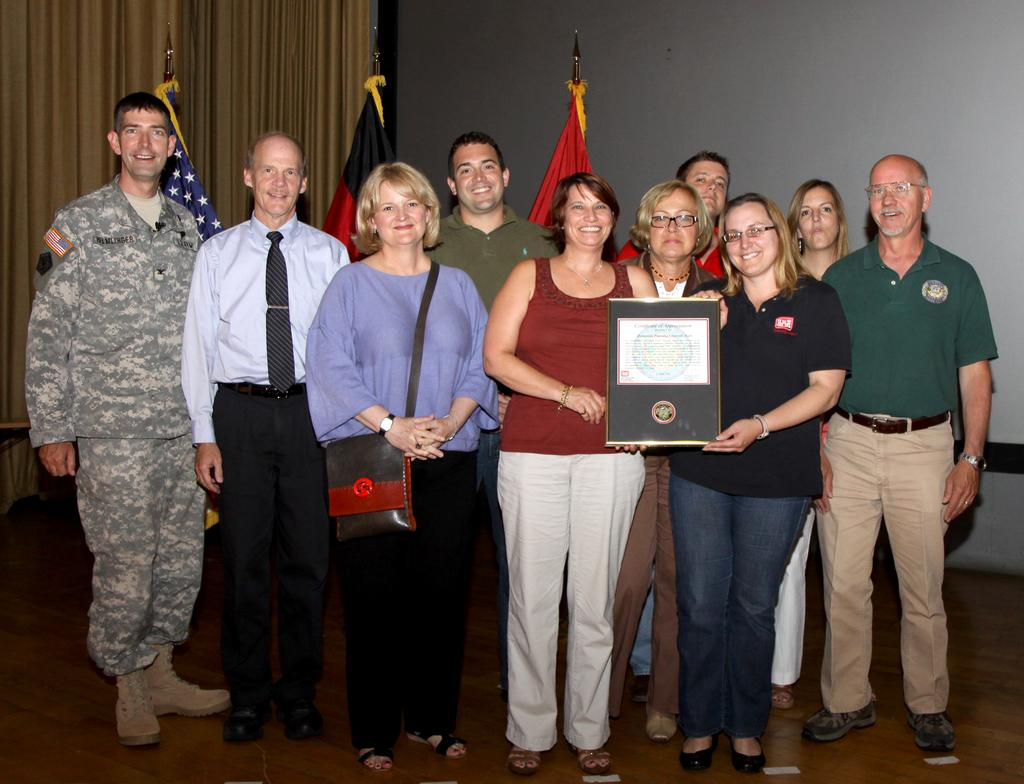What are the persons in the image doing? The persons in the image are standing on the floor. Can you describe what one of the persons is holding? One of the persons is holding a certificate in her hands. What can be seen in the background of the image? There are walls, curtains, flags, and flag posts in the background of the image. What type of yarn is being used to decorate the office in the image? There is no mention of an office or yarn in the image; it features persons standing on the floor and a background with walls, curtains, flags, and flag posts. 